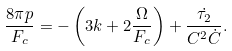Convert formula to latex. <formula><loc_0><loc_0><loc_500><loc_500>\frac { 8 \pi p } { F _ { c } } = - \left ( 3 k + 2 \frac { \Omega } { F _ { c } } \right ) + \frac { \dot { \tau _ { 2 } } } { C ^ { 2 } \dot { C } } .</formula> 